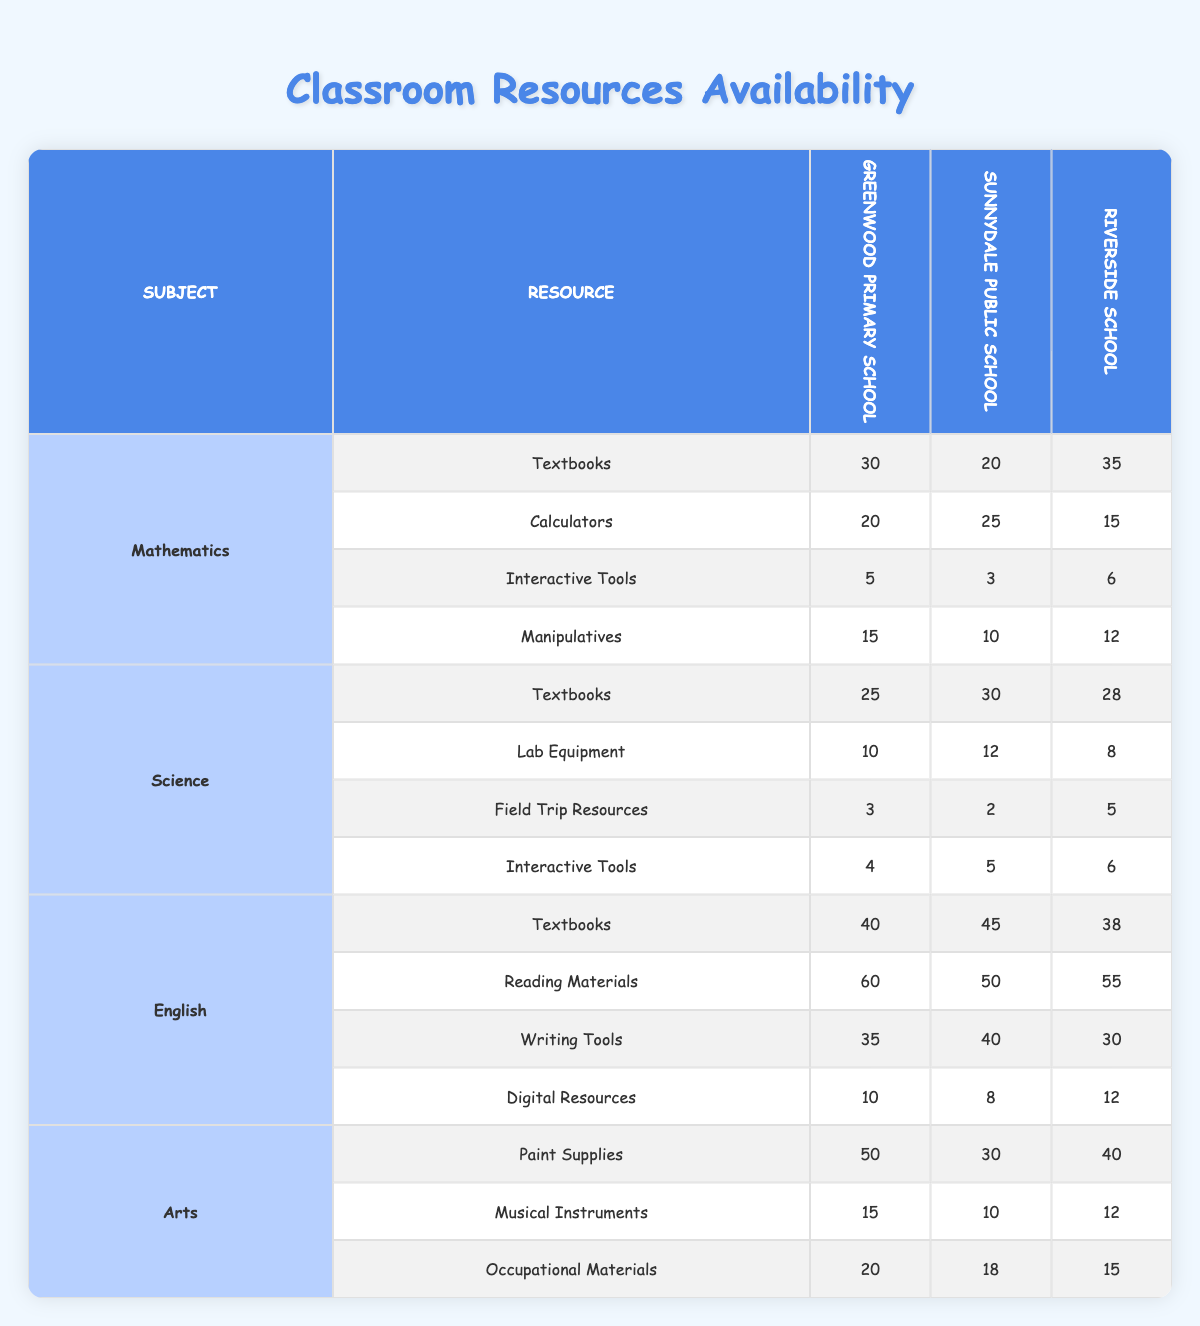What is the total number of mathematics textbooks available across all schools? The mathematics textbooks available in the schools are: Greenwood Primary School (30), Sunnydale Public School (20), and Riverside School (35). To get the total, we add these values: 30 + 20 + 35 = 85.
Answer: 85 Which school has the highest number of calculators for mathematics? Looking at the calculators data for mathematics: Greenwood Primary School has 20, Sunnydale Public School has 25, and Riverside School has 15. The highest value among these is 25, found at Sunnydale Public School.
Answer: Sunnydale Public School Are there more paint supplies in Greenwood Primary School than in Sunnydale Public School? Greenwood Primary School has 50 paint supplies while Sunnydale Public School has 30. Since 50 is greater than 30, the statement is true.
Answer: Yes What is the average number of writing tools available across all schools? The number of writing tools available are: Greenwood Primary School (35), Sunnydale Public School (40), and Riverside School (30). The average is calculated by summing these values: 35 + 40 + 30 = 105, and then dividing by 3 (the number of schools), which equals 105 / 3 = 35.
Answer: 35 How many more interactive tools does Riverside School have compared to Greenwood Primary School in mathematics? Riverside School has 6 interactive tools, while Greenwood Primary School has 5. The difference is: 6 - 5 = 1.
Answer: 1 Which subject area has the least availability of field trip resources? The field trip resources in each subject area are: Mathematics has 0 (not listed), Science has 3 (Greenwood), 2 (Sunnydale), 5 (Riverside). The lowest of these values is 0 in Mathematics, indicating no available resources listed for it.
Answer: Mathematics Is the total number of digital resources for English higher than the total for Arts? The digital resources are: English has 10 (Greenwood), 8 (Sunnydale), 12 (Riverside), totaling 30. The Arts show: 0 (not listed), 0 (not listed), and 0 (not listed) across all schools, totaling 0. Since 30 is greater than 0, the statement is true.
Answer: Yes What is the difference between the highest and lowest number of lab equipment available in science? The lab equipment counts are: Greenwood Primary School (10), Sunnydale Public School (12), and Riverside School (8). The highest is 12 (Sunnydale) and the lowest is 8 (Riverside). The difference is 12 - 8 = 4.
Answer: 4 Which school has the most manipulatives available in mathematics? The manipulatives by school are: Greenwood Primary School (15), Sunnydale Public School (10), and Riverside School (12). The highest value is 15, which belongs to Greenwood Primary School.
Answer: Greenwood Primary School 